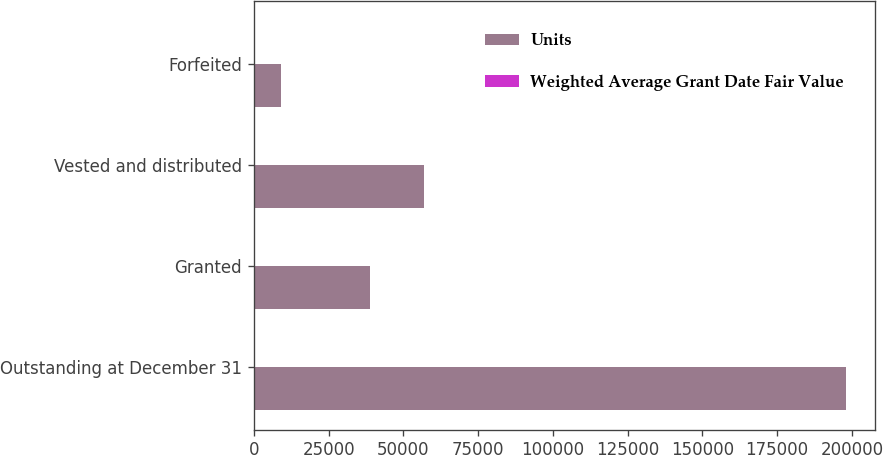<chart> <loc_0><loc_0><loc_500><loc_500><stacked_bar_chart><ecel><fcel>Outstanding at December 31<fcel>Granted<fcel>Vested and distributed<fcel>Forfeited<nl><fcel>Units<fcel>198000<fcel>39000<fcel>57000<fcel>9000<nl><fcel>Weighted Average Grant Date Fair Value<fcel>12.55<fcel>15.38<fcel>13.93<fcel>13.84<nl></chart> 